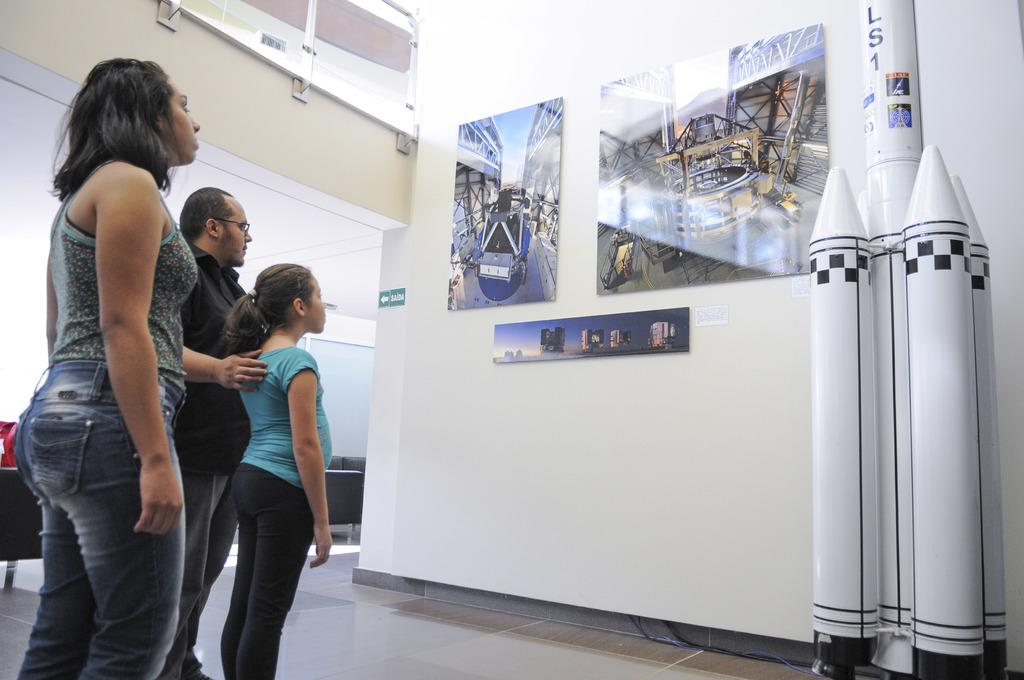What is the primary subject of the image? There is a kid and two adults in the image. What are the kid and adults doing in the image? They are looking at posters on the wall. What can be seen beside the wall in the image? There is a depiction of a rocket beside the wall. What is the main architectural feature in the image? There is a wall in the image. What type of lumber is being used to build the monkey's nest in the image? There is no monkey or nest present in the image, and therefore no lumber can be associated with it. What flavor of eggnog is being served to the adults in the image? There is no eggnog present in the image, and therefore no flavor can be determined. 